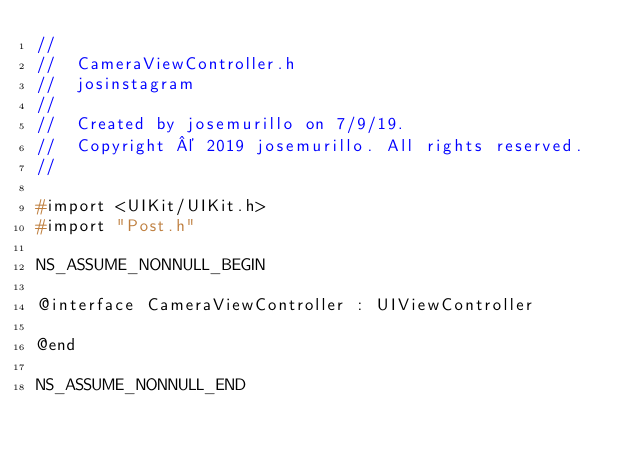Convert code to text. <code><loc_0><loc_0><loc_500><loc_500><_C_>//
//  CameraViewController.h
//  josinstagram
//
//  Created by josemurillo on 7/9/19.
//  Copyright © 2019 josemurillo. All rights reserved.
//

#import <UIKit/UIKit.h>
#import "Post.h"

NS_ASSUME_NONNULL_BEGIN

@interface CameraViewController : UIViewController

@end

NS_ASSUME_NONNULL_END
</code> 